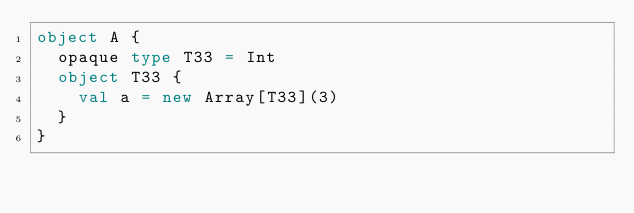Convert code to text. <code><loc_0><loc_0><loc_500><loc_500><_Scala_>object A {
  opaque type T33 = Int
  object T33 {
    val a = new Array[T33](3)
  }
}</code> 